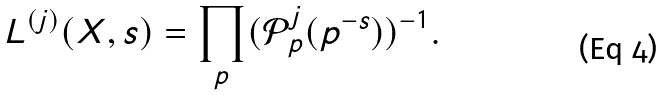<formula> <loc_0><loc_0><loc_500><loc_500>L ^ { ( j ) } ( X , s ) = \prod _ { p } ( { \mathcal { P } } _ { p } ^ { j } ( p ^ { - s } ) ) ^ { - 1 } .</formula> 